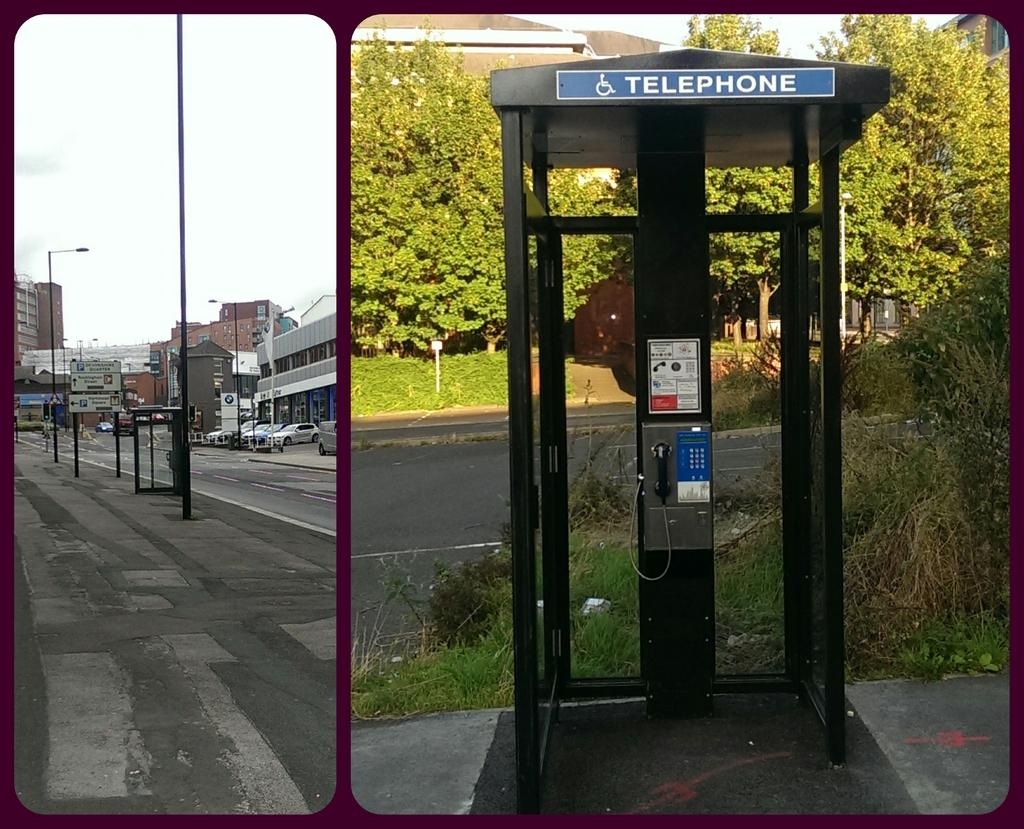Provide a one-sentence caption for the provided image. A telephone booth next to a street surrounded by trees. 